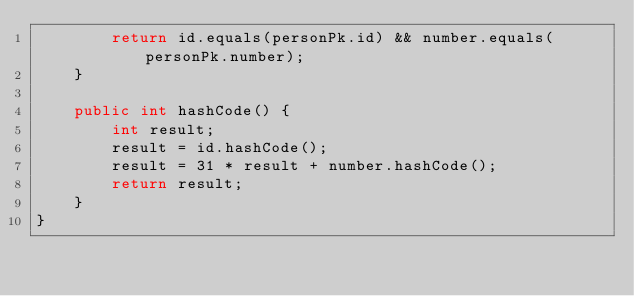Convert code to text. <code><loc_0><loc_0><loc_500><loc_500><_Java_>        return id.equals(personPk.id) && number.equals(personPk.number);
    }

    public int hashCode() {
        int result;
        result = id.hashCode();
        result = 31 * result + number.hashCode();
        return result;
    }
}
</code> 